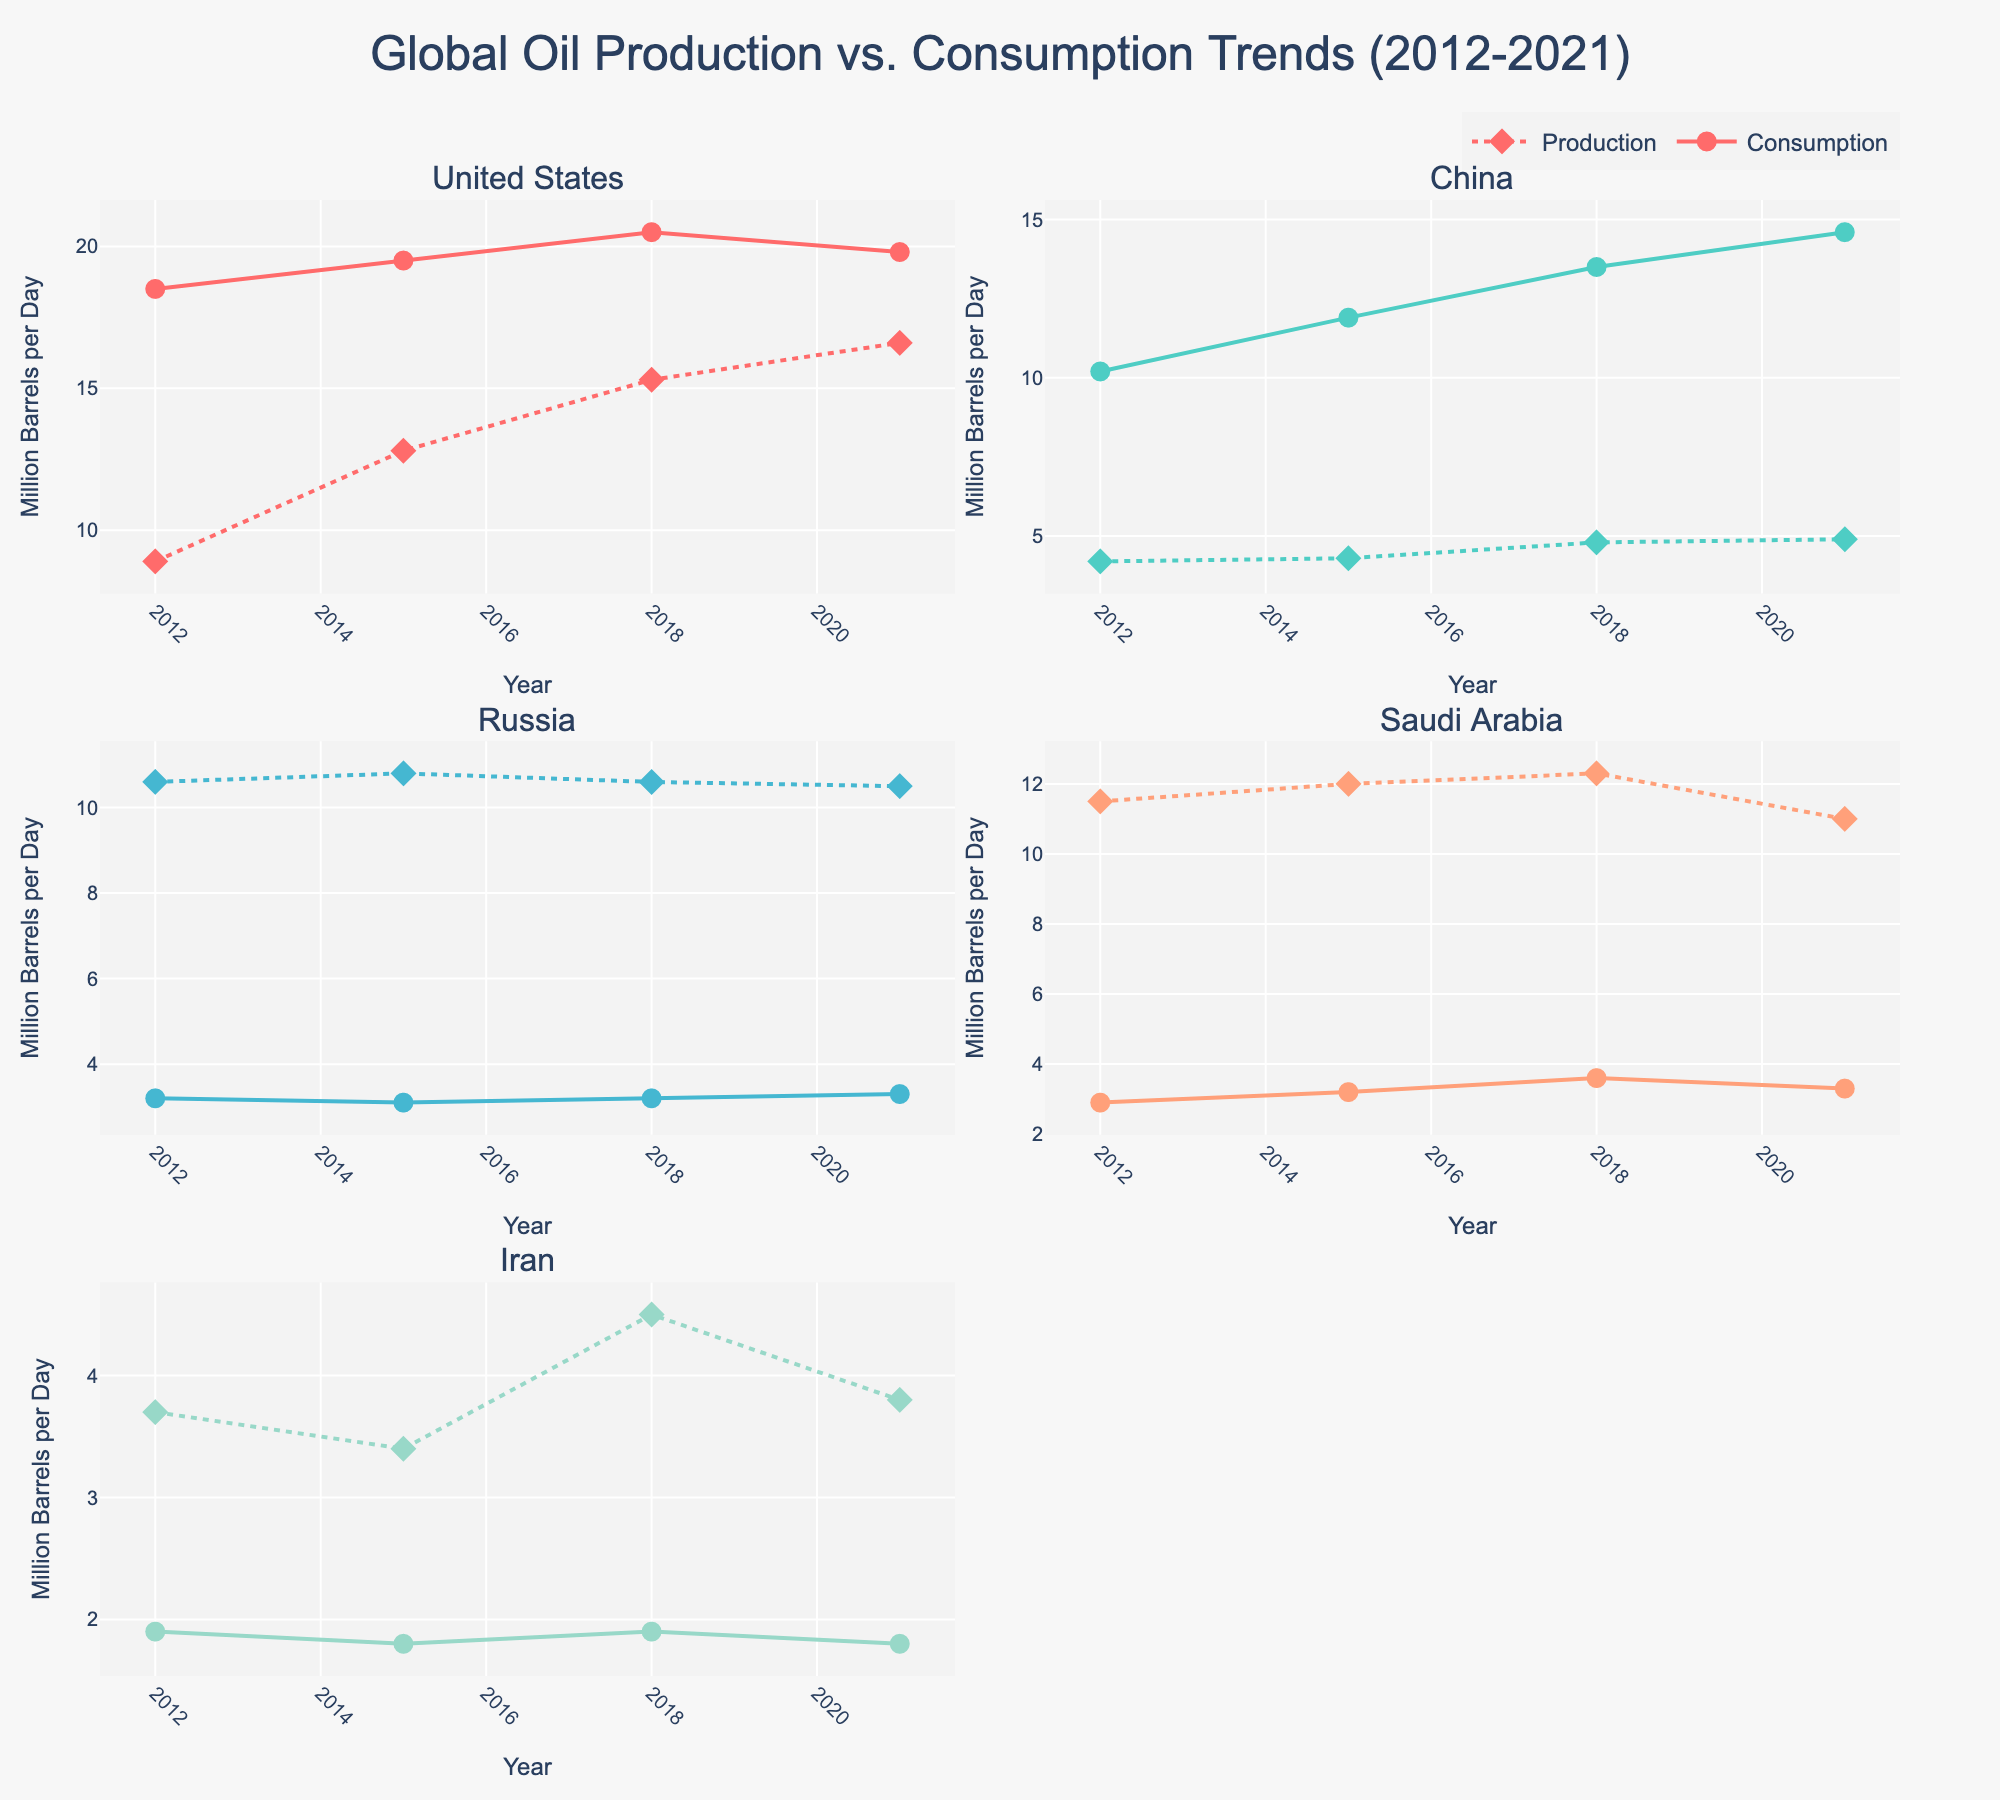What is the title of the figure? The title of the figure is prominently displayed at the top and reads "Global Oil Production vs. Consumption Trends (2012-2021)"
Answer: Global Oil Production vs. Consumption Trends (2012-2021) Which country shows a consistent increase in oil consumption from 2012 to 2021? By examining the subplot dedicated to each country, China shows a consistent increase in consumption, steadily rising from 10.2 in 2012 to 14.6 in 2021
Answer: China How has Iran's oil production changed from 2012 to 2021? Referring to Iran's subplot, the production values are shown to fluctuate slightly but overall trend indicates a decrease from 3.7 in 2012 to 3.8 in 2021
Answer: Decreased In 2018, which country has the highest oil production and what is the value? By looking at the 2018 data points across all subplots, the highest value for production is for the United States at 15.3 million barrels per day
Answer: United States, 15.3 million barrels per day Which country's oil production is greater than its consumption across all the years? By examining the consumption and production lines for each country, Russia consistently shows higher production than consumption across all years from 2012 to 2021
Answer: Russia What is the general trend of the United States' oil production and consumption from 2012 to 2021? The subplot for the United States reveals both production and consumption trends; production shows a marked increase from 8.9 in 2012 to 16.6 in 2021, while consumption also increases but more gradually from 18.5 to 19.8
Answer: Increasing production, gradually increasing consumption Compare the consumption trends between Saudi Arabia and Iran from 2012 to 2021. On examining their respective subplots, Saudi Arabia’s consumption generally increases from 2.9 to 3.3, whereas Iran’s fluctuates but ends similarly around 1.8-1.9
Answer: Saudi Arabia: Increasing; Iran: Stable What is the average oil consumption of the United States from 2012 to 2021? The consumption values for the United States over the years are 18.5, 19.5, 20.5, and 19.8. Adding these values gives 78.3, and dividing by 4 (number of years) results in 19.575
Answer: 19.575 Which year shows the highest consumption for China? Reviewing the plotted data for China in terms of consumption, the highest value appears in 2021 with 14.6
Answer: 2021 Is Saudi Arabia's oil production higher in 2018 or 2021? By referring to the Saudi Arabia subplot, the production in 2018 is shown as 12.3, whereas in 2021 it is 11.0. Therefore, production is higher in 2018
Answer: 2018 